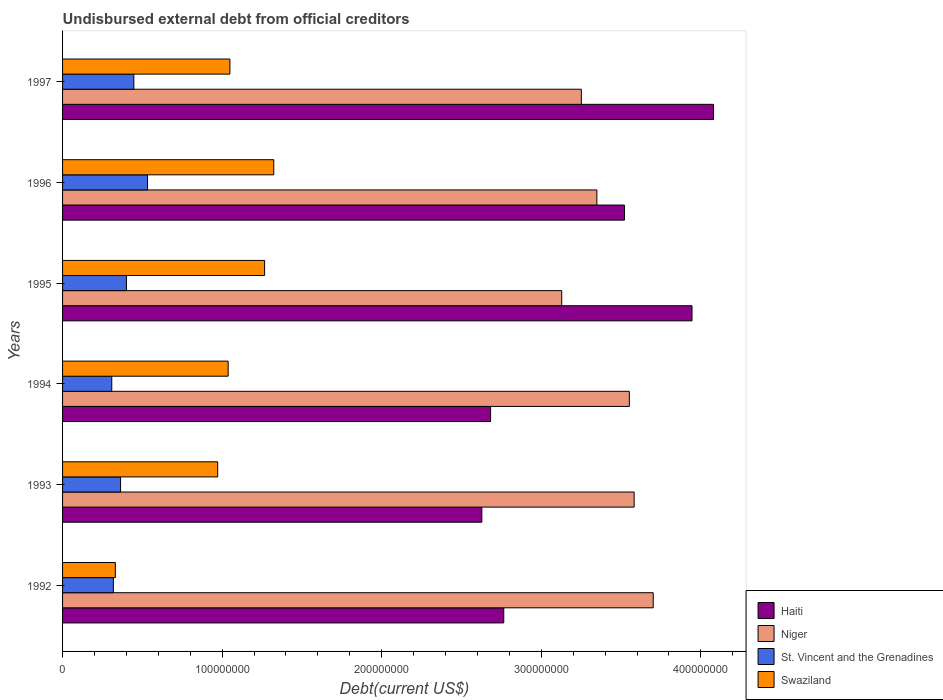Are the number of bars per tick equal to the number of legend labels?
Provide a succinct answer. Yes. Are the number of bars on each tick of the Y-axis equal?
Offer a terse response. Yes. What is the total debt in Haiti in 1997?
Provide a short and direct response. 4.08e+08. Across all years, what is the maximum total debt in Swaziland?
Offer a very short reply. 1.32e+08. Across all years, what is the minimum total debt in Niger?
Make the answer very short. 3.13e+08. In which year was the total debt in Haiti minimum?
Your answer should be compact. 1993. What is the total total debt in Haiti in the graph?
Your response must be concise. 1.96e+09. What is the difference between the total debt in St. Vincent and the Grenadines in 1995 and that in 1997?
Provide a succinct answer. -4.65e+06. What is the difference between the total debt in St. Vincent and the Grenadines in 1992 and the total debt in Niger in 1996?
Provide a succinct answer. -3.03e+08. What is the average total debt in Haiti per year?
Provide a short and direct response. 3.27e+08. In the year 1992, what is the difference between the total debt in St. Vincent and the Grenadines and total debt in Haiti?
Offer a very short reply. -2.45e+08. What is the ratio of the total debt in Haiti in 1995 to that in 1997?
Keep it short and to the point. 0.97. Is the total debt in Swaziland in 1992 less than that in 1996?
Your answer should be very brief. Yes. Is the difference between the total debt in St. Vincent and the Grenadines in 1994 and 1996 greater than the difference between the total debt in Haiti in 1994 and 1996?
Make the answer very short. Yes. What is the difference between the highest and the second highest total debt in Swaziland?
Your answer should be very brief. 5.76e+06. What is the difference between the highest and the lowest total debt in Swaziland?
Keep it short and to the point. 9.93e+07. In how many years, is the total debt in Niger greater than the average total debt in Niger taken over all years?
Your answer should be compact. 3. Is the sum of the total debt in Niger in 1993 and 1995 greater than the maximum total debt in Swaziland across all years?
Provide a succinct answer. Yes. Is it the case that in every year, the sum of the total debt in St. Vincent and the Grenadines and total debt in Swaziland is greater than the sum of total debt in Niger and total debt in Haiti?
Provide a short and direct response. No. What does the 1st bar from the top in 1993 represents?
Offer a very short reply. Swaziland. What does the 4th bar from the bottom in 1996 represents?
Provide a succinct answer. Swaziland. Is it the case that in every year, the sum of the total debt in Swaziland and total debt in Niger is greater than the total debt in St. Vincent and the Grenadines?
Give a very brief answer. Yes. How many bars are there?
Your answer should be very brief. 24. How many years are there in the graph?
Give a very brief answer. 6. Are the values on the major ticks of X-axis written in scientific E-notation?
Your answer should be compact. No. Where does the legend appear in the graph?
Offer a terse response. Bottom right. How many legend labels are there?
Give a very brief answer. 4. How are the legend labels stacked?
Ensure brevity in your answer.  Vertical. What is the title of the graph?
Your response must be concise. Undisbursed external debt from official creditors. What is the label or title of the X-axis?
Your response must be concise. Debt(current US$). What is the label or title of the Y-axis?
Offer a terse response. Years. What is the Debt(current US$) of Haiti in 1992?
Provide a short and direct response. 2.76e+08. What is the Debt(current US$) in Niger in 1992?
Give a very brief answer. 3.70e+08. What is the Debt(current US$) in St. Vincent and the Grenadines in 1992?
Ensure brevity in your answer.  3.18e+07. What is the Debt(current US$) in Swaziland in 1992?
Keep it short and to the point. 3.31e+07. What is the Debt(current US$) of Haiti in 1993?
Your answer should be compact. 2.63e+08. What is the Debt(current US$) of Niger in 1993?
Your answer should be very brief. 3.58e+08. What is the Debt(current US$) of St. Vincent and the Grenadines in 1993?
Your answer should be compact. 3.64e+07. What is the Debt(current US$) in Swaziland in 1993?
Your response must be concise. 9.72e+07. What is the Debt(current US$) in Haiti in 1994?
Provide a short and direct response. 2.68e+08. What is the Debt(current US$) of Niger in 1994?
Provide a succinct answer. 3.55e+08. What is the Debt(current US$) of St. Vincent and the Grenadines in 1994?
Offer a terse response. 3.08e+07. What is the Debt(current US$) of Swaziland in 1994?
Offer a very short reply. 1.04e+08. What is the Debt(current US$) in Haiti in 1995?
Make the answer very short. 3.94e+08. What is the Debt(current US$) in Niger in 1995?
Your answer should be very brief. 3.13e+08. What is the Debt(current US$) of St. Vincent and the Grenadines in 1995?
Keep it short and to the point. 4.00e+07. What is the Debt(current US$) in Swaziland in 1995?
Make the answer very short. 1.27e+08. What is the Debt(current US$) in Haiti in 1996?
Ensure brevity in your answer.  3.52e+08. What is the Debt(current US$) of Niger in 1996?
Offer a terse response. 3.35e+08. What is the Debt(current US$) in St. Vincent and the Grenadines in 1996?
Provide a short and direct response. 5.33e+07. What is the Debt(current US$) in Swaziland in 1996?
Provide a succinct answer. 1.32e+08. What is the Debt(current US$) of Haiti in 1997?
Offer a very short reply. 4.08e+08. What is the Debt(current US$) in Niger in 1997?
Your answer should be very brief. 3.25e+08. What is the Debt(current US$) of St. Vincent and the Grenadines in 1997?
Provide a succinct answer. 4.47e+07. What is the Debt(current US$) in Swaziland in 1997?
Give a very brief answer. 1.05e+08. Across all years, what is the maximum Debt(current US$) of Haiti?
Your response must be concise. 4.08e+08. Across all years, what is the maximum Debt(current US$) in Niger?
Your answer should be compact. 3.70e+08. Across all years, what is the maximum Debt(current US$) of St. Vincent and the Grenadines?
Your response must be concise. 5.33e+07. Across all years, what is the maximum Debt(current US$) of Swaziland?
Provide a succinct answer. 1.32e+08. Across all years, what is the minimum Debt(current US$) in Haiti?
Make the answer very short. 2.63e+08. Across all years, what is the minimum Debt(current US$) of Niger?
Provide a succinct answer. 3.13e+08. Across all years, what is the minimum Debt(current US$) of St. Vincent and the Grenadines?
Your response must be concise. 3.08e+07. Across all years, what is the minimum Debt(current US$) of Swaziland?
Keep it short and to the point. 3.31e+07. What is the total Debt(current US$) of Haiti in the graph?
Offer a terse response. 1.96e+09. What is the total Debt(current US$) of Niger in the graph?
Give a very brief answer. 2.06e+09. What is the total Debt(current US$) of St. Vincent and the Grenadines in the graph?
Your answer should be compact. 2.37e+08. What is the total Debt(current US$) in Swaziland in the graph?
Provide a succinct answer. 5.98e+08. What is the difference between the Debt(current US$) of Haiti in 1992 and that in 1993?
Your response must be concise. 1.37e+07. What is the difference between the Debt(current US$) of Niger in 1992 and that in 1993?
Keep it short and to the point. 1.20e+07. What is the difference between the Debt(current US$) of St. Vincent and the Grenadines in 1992 and that in 1993?
Provide a succinct answer. -4.53e+06. What is the difference between the Debt(current US$) in Swaziland in 1992 and that in 1993?
Provide a succinct answer. -6.41e+07. What is the difference between the Debt(current US$) of Haiti in 1992 and that in 1994?
Your answer should be very brief. 8.25e+06. What is the difference between the Debt(current US$) of Niger in 1992 and that in 1994?
Your answer should be very brief. 1.50e+07. What is the difference between the Debt(current US$) of St. Vincent and the Grenadines in 1992 and that in 1994?
Your response must be concise. 9.99e+05. What is the difference between the Debt(current US$) of Swaziland in 1992 and that in 1994?
Make the answer very short. -7.07e+07. What is the difference between the Debt(current US$) of Haiti in 1992 and that in 1995?
Provide a short and direct response. -1.18e+08. What is the difference between the Debt(current US$) of Niger in 1992 and that in 1995?
Your answer should be compact. 5.73e+07. What is the difference between the Debt(current US$) of St. Vincent and the Grenadines in 1992 and that in 1995?
Provide a succinct answer. -8.20e+06. What is the difference between the Debt(current US$) in Swaziland in 1992 and that in 1995?
Offer a very short reply. -9.35e+07. What is the difference between the Debt(current US$) in Haiti in 1992 and that in 1996?
Give a very brief answer. -7.57e+07. What is the difference between the Debt(current US$) of Niger in 1992 and that in 1996?
Your answer should be compact. 3.53e+07. What is the difference between the Debt(current US$) of St. Vincent and the Grenadines in 1992 and that in 1996?
Make the answer very short. -2.14e+07. What is the difference between the Debt(current US$) in Swaziland in 1992 and that in 1996?
Provide a short and direct response. -9.93e+07. What is the difference between the Debt(current US$) of Haiti in 1992 and that in 1997?
Your answer should be very brief. -1.31e+08. What is the difference between the Debt(current US$) of Niger in 1992 and that in 1997?
Your response must be concise. 4.50e+07. What is the difference between the Debt(current US$) in St. Vincent and the Grenadines in 1992 and that in 1997?
Offer a terse response. -1.28e+07. What is the difference between the Debt(current US$) in Swaziland in 1992 and that in 1997?
Offer a terse response. -7.18e+07. What is the difference between the Debt(current US$) of Haiti in 1993 and that in 1994?
Make the answer very short. -5.49e+06. What is the difference between the Debt(current US$) of Niger in 1993 and that in 1994?
Make the answer very short. 3.01e+06. What is the difference between the Debt(current US$) in St. Vincent and the Grenadines in 1993 and that in 1994?
Give a very brief answer. 5.52e+06. What is the difference between the Debt(current US$) of Swaziland in 1993 and that in 1994?
Offer a very short reply. -6.55e+06. What is the difference between the Debt(current US$) in Haiti in 1993 and that in 1995?
Provide a short and direct response. -1.32e+08. What is the difference between the Debt(current US$) in Niger in 1993 and that in 1995?
Give a very brief answer. 4.54e+07. What is the difference between the Debt(current US$) of St. Vincent and the Grenadines in 1993 and that in 1995?
Your answer should be very brief. -3.68e+06. What is the difference between the Debt(current US$) of Swaziland in 1993 and that in 1995?
Ensure brevity in your answer.  -2.94e+07. What is the difference between the Debt(current US$) of Haiti in 1993 and that in 1996?
Your response must be concise. -8.94e+07. What is the difference between the Debt(current US$) in Niger in 1993 and that in 1996?
Offer a terse response. 2.34e+07. What is the difference between the Debt(current US$) of St. Vincent and the Grenadines in 1993 and that in 1996?
Offer a very short reply. -1.69e+07. What is the difference between the Debt(current US$) in Swaziland in 1993 and that in 1996?
Offer a very short reply. -3.51e+07. What is the difference between the Debt(current US$) of Haiti in 1993 and that in 1997?
Ensure brevity in your answer.  -1.45e+08. What is the difference between the Debt(current US$) in Niger in 1993 and that in 1997?
Offer a terse response. 3.31e+07. What is the difference between the Debt(current US$) of St. Vincent and the Grenadines in 1993 and that in 1997?
Ensure brevity in your answer.  -8.32e+06. What is the difference between the Debt(current US$) in Swaziland in 1993 and that in 1997?
Provide a short and direct response. -7.65e+06. What is the difference between the Debt(current US$) in Haiti in 1994 and that in 1995?
Keep it short and to the point. -1.26e+08. What is the difference between the Debt(current US$) in Niger in 1994 and that in 1995?
Offer a terse response. 4.24e+07. What is the difference between the Debt(current US$) in St. Vincent and the Grenadines in 1994 and that in 1995?
Your answer should be very brief. -9.20e+06. What is the difference between the Debt(current US$) of Swaziland in 1994 and that in 1995?
Keep it short and to the point. -2.28e+07. What is the difference between the Debt(current US$) of Haiti in 1994 and that in 1996?
Ensure brevity in your answer.  -8.39e+07. What is the difference between the Debt(current US$) in Niger in 1994 and that in 1996?
Provide a succinct answer. 2.03e+07. What is the difference between the Debt(current US$) in St. Vincent and the Grenadines in 1994 and that in 1996?
Provide a succinct answer. -2.24e+07. What is the difference between the Debt(current US$) in Swaziland in 1994 and that in 1996?
Offer a terse response. -2.86e+07. What is the difference between the Debt(current US$) in Haiti in 1994 and that in 1997?
Offer a terse response. -1.40e+08. What is the difference between the Debt(current US$) in Niger in 1994 and that in 1997?
Offer a terse response. 3.01e+07. What is the difference between the Debt(current US$) in St. Vincent and the Grenadines in 1994 and that in 1997?
Ensure brevity in your answer.  -1.38e+07. What is the difference between the Debt(current US$) of Swaziland in 1994 and that in 1997?
Your response must be concise. -1.10e+06. What is the difference between the Debt(current US$) of Haiti in 1995 and that in 1996?
Your response must be concise. 4.23e+07. What is the difference between the Debt(current US$) of Niger in 1995 and that in 1996?
Make the answer very short. -2.20e+07. What is the difference between the Debt(current US$) in St. Vincent and the Grenadines in 1995 and that in 1996?
Keep it short and to the point. -1.32e+07. What is the difference between the Debt(current US$) of Swaziland in 1995 and that in 1996?
Your answer should be compact. -5.76e+06. What is the difference between the Debt(current US$) of Haiti in 1995 and that in 1997?
Provide a short and direct response. -1.35e+07. What is the difference between the Debt(current US$) of Niger in 1995 and that in 1997?
Offer a terse response. -1.23e+07. What is the difference between the Debt(current US$) in St. Vincent and the Grenadines in 1995 and that in 1997?
Your answer should be very brief. -4.65e+06. What is the difference between the Debt(current US$) in Swaziland in 1995 and that in 1997?
Ensure brevity in your answer.  2.17e+07. What is the difference between the Debt(current US$) in Haiti in 1996 and that in 1997?
Keep it short and to the point. -5.58e+07. What is the difference between the Debt(current US$) of Niger in 1996 and that in 1997?
Ensure brevity in your answer.  9.73e+06. What is the difference between the Debt(current US$) of St. Vincent and the Grenadines in 1996 and that in 1997?
Your answer should be very brief. 8.58e+06. What is the difference between the Debt(current US$) of Swaziland in 1996 and that in 1997?
Your answer should be very brief. 2.75e+07. What is the difference between the Debt(current US$) of Haiti in 1992 and the Debt(current US$) of Niger in 1993?
Provide a succinct answer. -8.17e+07. What is the difference between the Debt(current US$) in Haiti in 1992 and the Debt(current US$) in St. Vincent and the Grenadines in 1993?
Your answer should be compact. 2.40e+08. What is the difference between the Debt(current US$) in Haiti in 1992 and the Debt(current US$) in Swaziland in 1993?
Offer a very short reply. 1.79e+08. What is the difference between the Debt(current US$) of Niger in 1992 and the Debt(current US$) of St. Vincent and the Grenadines in 1993?
Ensure brevity in your answer.  3.34e+08. What is the difference between the Debt(current US$) in Niger in 1992 and the Debt(current US$) in Swaziland in 1993?
Your answer should be compact. 2.73e+08. What is the difference between the Debt(current US$) in St. Vincent and the Grenadines in 1992 and the Debt(current US$) in Swaziland in 1993?
Give a very brief answer. -6.54e+07. What is the difference between the Debt(current US$) of Haiti in 1992 and the Debt(current US$) of Niger in 1994?
Make the answer very short. -7.87e+07. What is the difference between the Debt(current US$) in Haiti in 1992 and the Debt(current US$) in St. Vincent and the Grenadines in 1994?
Provide a succinct answer. 2.46e+08. What is the difference between the Debt(current US$) in Haiti in 1992 and the Debt(current US$) in Swaziland in 1994?
Keep it short and to the point. 1.73e+08. What is the difference between the Debt(current US$) of Niger in 1992 and the Debt(current US$) of St. Vincent and the Grenadines in 1994?
Offer a terse response. 3.39e+08. What is the difference between the Debt(current US$) in Niger in 1992 and the Debt(current US$) in Swaziland in 1994?
Keep it short and to the point. 2.66e+08. What is the difference between the Debt(current US$) in St. Vincent and the Grenadines in 1992 and the Debt(current US$) in Swaziland in 1994?
Offer a terse response. -7.19e+07. What is the difference between the Debt(current US$) in Haiti in 1992 and the Debt(current US$) in Niger in 1995?
Your answer should be very brief. -3.63e+07. What is the difference between the Debt(current US$) of Haiti in 1992 and the Debt(current US$) of St. Vincent and the Grenadines in 1995?
Provide a short and direct response. 2.36e+08. What is the difference between the Debt(current US$) of Haiti in 1992 and the Debt(current US$) of Swaziland in 1995?
Your answer should be very brief. 1.50e+08. What is the difference between the Debt(current US$) in Niger in 1992 and the Debt(current US$) in St. Vincent and the Grenadines in 1995?
Your response must be concise. 3.30e+08. What is the difference between the Debt(current US$) of Niger in 1992 and the Debt(current US$) of Swaziland in 1995?
Your answer should be compact. 2.44e+08. What is the difference between the Debt(current US$) in St. Vincent and the Grenadines in 1992 and the Debt(current US$) in Swaziland in 1995?
Your answer should be compact. -9.48e+07. What is the difference between the Debt(current US$) in Haiti in 1992 and the Debt(current US$) in Niger in 1996?
Provide a succinct answer. -5.84e+07. What is the difference between the Debt(current US$) of Haiti in 1992 and the Debt(current US$) of St. Vincent and the Grenadines in 1996?
Ensure brevity in your answer.  2.23e+08. What is the difference between the Debt(current US$) of Haiti in 1992 and the Debt(current US$) of Swaziland in 1996?
Ensure brevity in your answer.  1.44e+08. What is the difference between the Debt(current US$) of Niger in 1992 and the Debt(current US$) of St. Vincent and the Grenadines in 1996?
Give a very brief answer. 3.17e+08. What is the difference between the Debt(current US$) in Niger in 1992 and the Debt(current US$) in Swaziland in 1996?
Your response must be concise. 2.38e+08. What is the difference between the Debt(current US$) in St. Vincent and the Grenadines in 1992 and the Debt(current US$) in Swaziland in 1996?
Offer a terse response. -1.01e+08. What is the difference between the Debt(current US$) of Haiti in 1992 and the Debt(current US$) of Niger in 1997?
Keep it short and to the point. -4.86e+07. What is the difference between the Debt(current US$) of Haiti in 1992 and the Debt(current US$) of St. Vincent and the Grenadines in 1997?
Your response must be concise. 2.32e+08. What is the difference between the Debt(current US$) in Haiti in 1992 and the Debt(current US$) in Swaziland in 1997?
Your answer should be compact. 1.72e+08. What is the difference between the Debt(current US$) in Niger in 1992 and the Debt(current US$) in St. Vincent and the Grenadines in 1997?
Keep it short and to the point. 3.25e+08. What is the difference between the Debt(current US$) in Niger in 1992 and the Debt(current US$) in Swaziland in 1997?
Offer a very short reply. 2.65e+08. What is the difference between the Debt(current US$) in St. Vincent and the Grenadines in 1992 and the Debt(current US$) in Swaziland in 1997?
Your response must be concise. -7.30e+07. What is the difference between the Debt(current US$) in Haiti in 1993 and the Debt(current US$) in Niger in 1994?
Make the answer very short. -9.24e+07. What is the difference between the Debt(current US$) in Haiti in 1993 and the Debt(current US$) in St. Vincent and the Grenadines in 1994?
Ensure brevity in your answer.  2.32e+08. What is the difference between the Debt(current US$) in Haiti in 1993 and the Debt(current US$) in Swaziland in 1994?
Keep it short and to the point. 1.59e+08. What is the difference between the Debt(current US$) in Niger in 1993 and the Debt(current US$) in St. Vincent and the Grenadines in 1994?
Ensure brevity in your answer.  3.27e+08. What is the difference between the Debt(current US$) in Niger in 1993 and the Debt(current US$) in Swaziland in 1994?
Provide a short and direct response. 2.54e+08. What is the difference between the Debt(current US$) in St. Vincent and the Grenadines in 1993 and the Debt(current US$) in Swaziland in 1994?
Ensure brevity in your answer.  -6.74e+07. What is the difference between the Debt(current US$) in Haiti in 1993 and the Debt(current US$) in Niger in 1995?
Provide a succinct answer. -5.01e+07. What is the difference between the Debt(current US$) in Haiti in 1993 and the Debt(current US$) in St. Vincent and the Grenadines in 1995?
Your answer should be compact. 2.23e+08. What is the difference between the Debt(current US$) of Haiti in 1993 and the Debt(current US$) of Swaziland in 1995?
Ensure brevity in your answer.  1.36e+08. What is the difference between the Debt(current US$) in Niger in 1993 and the Debt(current US$) in St. Vincent and the Grenadines in 1995?
Make the answer very short. 3.18e+08. What is the difference between the Debt(current US$) of Niger in 1993 and the Debt(current US$) of Swaziland in 1995?
Keep it short and to the point. 2.32e+08. What is the difference between the Debt(current US$) of St. Vincent and the Grenadines in 1993 and the Debt(current US$) of Swaziland in 1995?
Make the answer very short. -9.02e+07. What is the difference between the Debt(current US$) of Haiti in 1993 and the Debt(current US$) of Niger in 1996?
Your response must be concise. -7.21e+07. What is the difference between the Debt(current US$) of Haiti in 1993 and the Debt(current US$) of St. Vincent and the Grenadines in 1996?
Your response must be concise. 2.10e+08. What is the difference between the Debt(current US$) of Haiti in 1993 and the Debt(current US$) of Swaziland in 1996?
Offer a terse response. 1.30e+08. What is the difference between the Debt(current US$) in Niger in 1993 and the Debt(current US$) in St. Vincent and the Grenadines in 1996?
Offer a very short reply. 3.05e+08. What is the difference between the Debt(current US$) in Niger in 1993 and the Debt(current US$) in Swaziland in 1996?
Keep it short and to the point. 2.26e+08. What is the difference between the Debt(current US$) of St. Vincent and the Grenadines in 1993 and the Debt(current US$) of Swaziland in 1996?
Offer a very short reply. -9.60e+07. What is the difference between the Debt(current US$) in Haiti in 1993 and the Debt(current US$) in Niger in 1997?
Provide a succinct answer. -6.24e+07. What is the difference between the Debt(current US$) of Haiti in 1993 and the Debt(current US$) of St. Vincent and the Grenadines in 1997?
Your response must be concise. 2.18e+08. What is the difference between the Debt(current US$) of Haiti in 1993 and the Debt(current US$) of Swaziland in 1997?
Ensure brevity in your answer.  1.58e+08. What is the difference between the Debt(current US$) in Niger in 1993 and the Debt(current US$) in St. Vincent and the Grenadines in 1997?
Ensure brevity in your answer.  3.14e+08. What is the difference between the Debt(current US$) of Niger in 1993 and the Debt(current US$) of Swaziland in 1997?
Your answer should be compact. 2.53e+08. What is the difference between the Debt(current US$) in St. Vincent and the Grenadines in 1993 and the Debt(current US$) in Swaziland in 1997?
Make the answer very short. -6.85e+07. What is the difference between the Debt(current US$) of Haiti in 1994 and the Debt(current US$) of Niger in 1995?
Your response must be concise. -4.46e+07. What is the difference between the Debt(current US$) in Haiti in 1994 and the Debt(current US$) in St. Vincent and the Grenadines in 1995?
Give a very brief answer. 2.28e+08. What is the difference between the Debt(current US$) of Haiti in 1994 and the Debt(current US$) of Swaziland in 1995?
Offer a very short reply. 1.42e+08. What is the difference between the Debt(current US$) of Niger in 1994 and the Debt(current US$) of St. Vincent and the Grenadines in 1995?
Your answer should be compact. 3.15e+08. What is the difference between the Debt(current US$) in Niger in 1994 and the Debt(current US$) in Swaziland in 1995?
Keep it short and to the point. 2.29e+08. What is the difference between the Debt(current US$) in St. Vincent and the Grenadines in 1994 and the Debt(current US$) in Swaziland in 1995?
Your answer should be very brief. -9.58e+07. What is the difference between the Debt(current US$) in Haiti in 1994 and the Debt(current US$) in Niger in 1996?
Make the answer very short. -6.66e+07. What is the difference between the Debt(current US$) in Haiti in 1994 and the Debt(current US$) in St. Vincent and the Grenadines in 1996?
Offer a very short reply. 2.15e+08. What is the difference between the Debt(current US$) of Haiti in 1994 and the Debt(current US$) of Swaziland in 1996?
Make the answer very short. 1.36e+08. What is the difference between the Debt(current US$) in Niger in 1994 and the Debt(current US$) in St. Vincent and the Grenadines in 1996?
Make the answer very short. 3.02e+08. What is the difference between the Debt(current US$) in Niger in 1994 and the Debt(current US$) in Swaziland in 1996?
Offer a very short reply. 2.23e+08. What is the difference between the Debt(current US$) in St. Vincent and the Grenadines in 1994 and the Debt(current US$) in Swaziland in 1996?
Keep it short and to the point. -1.02e+08. What is the difference between the Debt(current US$) in Haiti in 1994 and the Debt(current US$) in Niger in 1997?
Your answer should be compact. -5.69e+07. What is the difference between the Debt(current US$) in Haiti in 1994 and the Debt(current US$) in St. Vincent and the Grenadines in 1997?
Provide a short and direct response. 2.24e+08. What is the difference between the Debt(current US$) in Haiti in 1994 and the Debt(current US$) in Swaziland in 1997?
Your answer should be very brief. 1.63e+08. What is the difference between the Debt(current US$) of Niger in 1994 and the Debt(current US$) of St. Vincent and the Grenadines in 1997?
Provide a succinct answer. 3.11e+08. What is the difference between the Debt(current US$) of Niger in 1994 and the Debt(current US$) of Swaziland in 1997?
Your answer should be very brief. 2.50e+08. What is the difference between the Debt(current US$) of St. Vincent and the Grenadines in 1994 and the Debt(current US$) of Swaziland in 1997?
Your answer should be very brief. -7.40e+07. What is the difference between the Debt(current US$) in Haiti in 1995 and the Debt(current US$) in Niger in 1996?
Give a very brief answer. 5.96e+07. What is the difference between the Debt(current US$) of Haiti in 1995 and the Debt(current US$) of St. Vincent and the Grenadines in 1996?
Offer a terse response. 3.41e+08. What is the difference between the Debt(current US$) of Haiti in 1995 and the Debt(current US$) of Swaziland in 1996?
Make the answer very short. 2.62e+08. What is the difference between the Debt(current US$) in Niger in 1995 and the Debt(current US$) in St. Vincent and the Grenadines in 1996?
Ensure brevity in your answer.  2.60e+08. What is the difference between the Debt(current US$) of Niger in 1995 and the Debt(current US$) of Swaziland in 1996?
Your answer should be compact. 1.80e+08. What is the difference between the Debt(current US$) in St. Vincent and the Grenadines in 1995 and the Debt(current US$) in Swaziland in 1996?
Give a very brief answer. -9.23e+07. What is the difference between the Debt(current US$) of Haiti in 1995 and the Debt(current US$) of Niger in 1997?
Provide a short and direct response. 6.94e+07. What is the difference between the Debt(current US$) of Haiti in 1995 and the Debt(current US$) of St. Vincent and the Grenadines in 1997?
Make the answer very short. 3.50e+08. What is the difference between the Debt(current US$) of Haiti in 1995 and the Debt(current US$) of Swaziland in 1997?
Provide a succinct answer. 2.90e+08. What is the difference between the Debt(current US$) of Niger in 1995 and the Debt(current US$) of St. Vincent and the Grenadines in 1997?
Give a very brief answer. 2.68e+08. What is the difference between the Debt(current US$) of Niger in 1995 and the Debt(current US$) of Swaziland in 1997?
Offer a terse response. 2.08e+08. What is the difference between the Debt(current US$) of St. Vincent and the Grenadines in 1995 and the Debt(current US$) of Swaziland in 1997?
Your answer should be very brief. -6.48e+07. What is the difference between the Debt(current US$) of Haiti in 1996 and the Debt(current US$) of Niger in 1997?
Offer a terse response. 2.70e+07. What is the difference between the Debt(current US$) of Haiti in 1996 and the Debt(current US$) of St. Vincent and the Grenadines in 1997?
Your answer should be very brief. 3.07e+08. What is the difference between the Debt(current US$) of Haiti in 1996 and the Debt(current US$) of Swaziland in 1997?
Keep it short and to the point. 2.47e+08. What is the difference between the Debt(current US$) in Niger in 1996 and the Debt(current US$) in St. Vincent and the Grenadines in 1997?
Ensure brevity in your answer.  2.90e+08. What is the difference between the Debt(current US$) in Niger in 1996 and the Debt(current US$) in Swaziland in 1997?
Your answer should be very brief. 2.30e+08. What is the difference between the Debt(current US$) in St. Vincent and the Grenadines in 1996 and the Debt(current US$) in Swaziland in 1997?
Keep it short and to the point. -5.16e+07. What is the average Debt(current US$) in Haiti per year?
Provide a short and direct response. 3.27e+08. What is the average Debt(current US$) in Niger per year?
Give a very brief answer. 3.43e+08. What is the average Debt(current US$) in St. Vincent and the Grenadines per year?
Provide a short and direct response. 3.95e+07. What is the average Debt(current US$) in Swaziland per year?
Give a very brief answer. 9.97e+07. In the year 1992, what is the difference between the Debt(current US$) in Haiti and Debt(current US$) in Niger?
Provide a succinct answer. -9.37e+07. In the year 1992, what is the difference between the Debt(current US$) of Haiti and Debt(current US$) of St. Vincent and the Grenadines?
Your answer should be very brief. 2.45e+08. In the year 1992, what is the difference between the Debt(current US$) in Haiti and Debt(current US$) in Swaziland?
Ensure brevity in your answer.  2.43e+08. In the year 1992, what is the difference between the Debt(current US$) in Niger and Debt(current US$) in St. Vincent and the Grenadines?
Keep it short and to the point. 3.38e+08. In the year 1992, what is the difference between the Debt(current US$) of Niger and Debt(current US$) of Swaziland?
Provide a short and direct response. 3.37e+08. In the year 1992, what is the difference between the Debt(current US$) of St. Vincent and the Grenadines and Debt(current US$) of Swaziland?
Your response must be concise. -1.25e+06. In the year 1993, what is the difference between the Debt(current US$) in Haiti and Debt(current US$) in Niger?
Offer a very short reply. -9.54e+07. In the year 1993, what is the difference between the Debt(current US$) in Haiti and Debt(current US$) in St. Vincent and the Grenadines?
Provide a short and direct response. 2.26e+08. In the year 1993, what is the difference between the Debt(current US$) of Haiti and Debt(current US$) of Swaziland?
Give a very brief answer. 1.66e+08. In the year 1993, what is the difference between the Debt(current US$) in Niger and Debt(current US$) in St. Vincent and the Grenadines?
Offer a terse response. 3.22e+08. In the year 1993, what is the difference between the Debt(current US$) in Niger and Debt(current US$) in Swaziland?
Provide a succinct answer. 2.61e+08. In the year 1993, what is the difference between the Debt(current US$) of St. Vincent and the Grenadines and Debt(current US$) of Swaziland?
Keep it short and to the point. -6.09e+07. In the year 1994, what is the difference between the Debt(current US$) of Haiti and Debt(current US$) of Niger?
Make the answer very short. -8.69e+07. In the year 1994, what is the difference between the Debt(current US$) of Haiti and Debt(current US$) of St. Vincent and the Grenadines?
Offer a terse response. 2.37e+08. In the year 1994, what is the difference between the Debt(current US$) in Haiti and Debt(current US$) in Swaziland?
Offer a very short reply. 1.64e+08. In the year 1994, what is the difference between the Debt(current US$) in Niger and Debt(current US$) in St. Vincent and the Grenadines?
Your answer should be compact. 3.24e+08. In the year 1994, what is the difference between the Debt(current US$) of Niger and Debt(current US$) of Swaziland?
Your response must be concise. 2.51e+08. In the year 1994, what is the difference between the Debt(current US$) of St. Vincent and the Grenadines and Debt(current US$) of Swaziland?
Ensure brevity in your answer.  -7.29e+07. In the year 1995, what is the difference between the Debt(current US$) of Haiti and Debt(current US$) of Niger?
Provide a succinct answer. 8.17e+07. In the year 1995, what is the difference between the Debt(current US$) of Haiti and Debt(current US$) of St. Vincent and the Grenadines?
Your response must be concise. 3.54e+08. In the year 1995, what is the difference between the Debt(current US$) of Haiti and Debt(current US$) of Swaziland?
Provide a succinct answer. 2.68e+08. In the year 1995, what is the difference between the Debt(current US$) of Niger and Debt(current US$) of St. Vincent and the Grenadines?
Offer a very short reply. 2.73e+08. In the year 1995, what is the difference between the Debt(current US$) of Niger and Debt(current US$) of Swaziland?
Offer a terse response. 1.86e+08. In the year 1995, what is the difference between the Debt(current US$) in St. Vincent and the Grenadines and Debt(current US$) in Swaziland?
Offer a terse response. -8.66e+07. In the year 1996, what is the difference between the Debt(current US$) in Haiti and Debt(current US$) in Niger?
Provide a short and direct response. 1.73e+07. In the year 1996, what is the difference between the Debt(current US$) in Haiti and Debt(current US$) in St. Vincent and the Grenadines?
Your response must be concise. 2.99e+08. In the year 1996, what is the difference between the Debt(current US$) of Haiti and Debt(current US$) of Swaziland?
Give a very brief answer. 2.20e+08. In the year 1996, what is the difference between the Debt(current US$) in Niger and Debt(current US$) in St. Vincent and the Grenadines?
Your answer should be compact. 2.82e+08. In the year 1996, what is the difference between the Debt(current US$) of Niger and Debt(current US$) of Swaziland?
Offer a terse response. 2.02e+08. In the year 1996, what is the difference between the Debt(current US$) of St. Vincent and the Grenadines and Debt(current US$) of Swaziland?
Provide a short and direct response. -7.91e+07. In the year 1997, what is the difference between the Debt(current US$) in Haiti and Debt(current US$) in Niger?
Ensure brevity in your answer.  8.28e+07. In the year 1997, what is the difference between the Debt(current US$) in Haiti and Debt(current US$) in St. Vincent and the Grenadines?
Offer a very short reply. 3.63e+08. In the year 1997, what is the difference between the Debt(current US$) of Haiti and Debt(current US$) of Swaziland?
Provide a succinct answer. 3.03e+08. In the year 1997, what is the difference between the Debt(current US$) in Niger and Debt(current US$) in St. Vincent and the Grenadines?
Provide a short and direct response. 2.80e+08. In the year 1997, what is the difference between the Debt(current US$) in Niger and Debt(current US$) in Swaziland?
Give a very brief answer. 2.20e+08. In the year 1997, what is the difference between the Debt(current US$) of St. Vincent and the Grenadines and Debt(current US$) of Swaziland?
Your answer should be very brief. -6.02e+07. What is the ratio of the Debt(current US$) of Haiti in 1992 to that in 1993?
Provide a succinct answer. 1.05. What is the ratio of the Debt(current US$) in Niger in 1992 to that in 1993?
Offer a terse response. 1.03. What is the ratio of the Debt(current US$) in St. Vincent and the Grenadines in 1992 to that in 1993?
Make the answer very short. 0.88. What is the ratio of the Debt(current US$) of Swaziland in 1992 to that in 1993?
Give a very brief answer. 0.34. What is the ratio of the Debt(current US$) in Haiti in 1992 to that in 1994?
Your answer should be very brief. 1.03. What is the ratio of the Debt(current US$) in Niger in 1992 to that in 1994?
Give a very brief answer. 1.04. What is the ratio of the Debt(current US$) in St. Vincent and the Grenadines in 1992 to that in 1994?
Provide a short and direct response. 1.03. What is the ratio of the Debt(current US$) of Swaziland in 1992 to that in 1994?
Ensure brevity in your answer.  0.32. What is the ratio of the Debt(current US$) of Haiti in 1992 to that in 1995?
Provide a succinct answer. 0.7. What is the ratio of the Debt(current US$) in Niger in 1992 to that in 1995?
Give a very brief answer. 1.18. What is the ratio of the Debt(current US$) of St. Vincent and the Grenadines in 1992 to that in 1995?
Ensure brevity in your answer.  0.8. What is the ratio of the Debt(current US$) in Swaziland in 1992 to that in 1995?
Offer a terse response. 0.26. What is the ratio of the Debt(current US$) in Haiti in 1992 to that in 1996?
Offer a very short reply. 0.79. What is the ratio of the Debt(current US$) of Niger in 1992 to that in 1996?
Keep it short and to the point. 1.11. What is the ratio of the Debt(current US$) of St. Vincent and the Grenadines in 1992 to that in 1996?
Give a very brief answer. 0.6. What is the ratio of the Debt(current US$) of Swaziland in 1992 to that in 1996?
Give a very brief answer. 0.25. What is the ratio of the Debt(current US$) in Haiti in 1992 to that in 1997?
Offer a very short reply. 0.68. What is the ratio of the Debt(current US$) in Niger in 1992 to that in 1997?
Offer a terse response. 1.14. What is the ratio of the Debt(current US$) in St. Vincent and the Grenadines in 1992 to that in 1997?
Your answer should be very brief. 0.71. What is the ratio of the Debt(current US$) of Swaziland in 1992 to that in 1997?
Offer a terse response. 0.32. What is the ratio of the Debt(current US$) in Haiti in 1993 to that in 1994?
Keep it short and to the point. 0.98. What is the ratio of the Debt(current US$) in Niger in 1993 to that in 1994?
Make the answer very short. 1.01. What is the ratio of the Debt(current US$) of St. Vincent and the Grenadines in 1993 to that in 1994?
Your answer should be compact. 1.18. What is the ratio of the Debt(current US$) of Swaziland in 1993 to that in 1994?
Provide a short and direct response. 0.94. What is the ratio of the Debt(current US$) in Haiti in 1993 to that in 1995?
Provide a succinct answer. 0.67. What is the ratio of the Debt(current US$) in Niger in 1993 to that in 1995?
Give a very brief answer. 1.15. What is the ratio of the Debt(current US$) of St. Vincent and the Grenadines in 1993 to that in 1995?
Keep it short and to the point. 0.91. What is the ratio of the Debt(current US$) in Swaziland in 1993 to that in 1995?
Your answer should be compact. 0.77. What is the ratio of the Debt(current US$) in Haiti in 1993 to that in 1996?
Provide a succinct answer. 0.75. What is the ratio of the Debt(current US$) of Niger in 1993 to that in 1996?
Provide a short and direct response. 1.07. What is the ratio of the Debt(current US$) of St. Vincent and the Grenadines in 1993 to that in 1996?
Provide a succinct answer. 0.68. What is the ratio of the Debt(current US$) in Swaziland in 1993 to that in 1996?
Your answer should be compact. 0.73. What is the ratio of the Debt(current US$) of Haiti in 1993 to that in 1997?
Provide a short and direct response. 0.64. What is the ratio of the Debt(current US$) of Niger in 1993 to that in 1997?
Provide a succinct answer. 1.1. What is the ratio of the Debt(current US$) of St. Vincent and the Grenadines in 1993 to that in 1997?
Give a very brief answer. 0.81. What is the ratio of the Debt(current US$) in Swaziland in 1993 to that in 1997?
Offer a very short reply. 0.93. What is the ratio of the Debt(current US$) of Haiti in 1994 to that in 1995?
Offer a very short reply. 0.68. What is the ratio of the Debt(current US$) of Niger in 1994 to that in 1995?
Give a very brief answer. 1.14. What is the ratio of the Debt(current US$) in St. Vincent and the Grenadines in 1994 to that in 1995?
Offer a very short reply. 0.77. What is the ratio of the Debt(current US$) in Swaziland in 1994 to that in 1995?
Make the answer very short. 0.82. What is the ratio of the Debt(current US$) of Haiti in 1994 to that in 1996?
Provide a short and direct response. 0.76. What is the ratio of the Debt(current US$) in Niger in 1994 to that in 1996?
Make the answer very short. 1.06. What is the ratio of the Debt(current US$) of St. Vincent and the Grenadines in 1994 to that in 1996?
Provide a short and direct response. 0.58. What is the ratio of the Debt(current US$) of Swaziland in 1994 to that in 1996?
Keep it short and to the point. 0.78. What is the ratio of the Debt(current US$) of Haiti in 1994 to that in 1997?
Your response must be concise. 0.66. What is the ratio of the Debt(current US$) in Niger in 1994 to that in 1997?
Make the answer very short. 1.09. What is the ratio of the Debt(current US$) in St. Vincent and the Grenadines in 1994 to that in 1997?
Give a very brief answer. 0.69. What is the ratio of the Debt(current US$) of Swaziland in 1994 to that in 1997?
Your response must be concise. 0.99. What is the ratio of the Debt(current US$) of Haiti in 1995 to that in 1996?
Your answer should be compact. 1.12. What is the ratio of the Debt(current US$) in Niger in 1995 to that in 1996?
Offer a terse response. 0.93. What is the ratio of the Debt(current US$) of St. Vincent and the Grenadines in 1995 to that in 1996?
Provide a short and direct response. 0.75. What is the ratio of the Debt(current US$) in Swaziland in 1995 to that in 1996?
Give a very brief answer. 0.96. What is the ratio of the Debt(current US$) in Haiti in 1995 to that in 1997?
Offer a terse response. 0.97. What is the ratio of the Debt(current US$) in Niger in 1995 to that in 1997?
Your answer should be compact. 0.96. What is the ratio of the Debt(current US$) in St. Vincent and the Grenadines in 1995 to that in 1997?
Give a very brief answer. 0.9. What is the ratio of the Debt(current US$) of Swaziland in 1995 to that in 1997?
Provide a succinct answer. 1.21. What is the ratio of the Debt(current US$) of Haiti in 1996 to that in 1997?
Your answer should be very brief. 0.86. What is the ratio of the Debt(current US$) in Niger in 1996 to that in 1997?
Your answer should be very brief. 1.03. What is the ratio of the Debt(current US$) in St. Vincent and the Grenadines in 1996 to that in 1997?
Give a very brief answer. 1.19. What is the ratio of the Debt(current US$) of Swaziland in 1996 to that in 1997?
Your answer should be very brief. 1.26. What is the difference between the highest and the second highest Debt(current US$) of Haiti?
Ensure brevity in your answer.  1.35e+07. What is the difference between the highest and the second highest Debt(current US$) in Niger?
Your response must be concise. 1.20e+07. What is the difference between the highest and the second highest Debt(current US$) of St. Vincent and the Grenadines?
Offer a terse response. 8.58e+06. What is the difference between the highest and the second highest Debt(current US$) in Swaziland?
Keep it short and to the point. 5.76e+06. What is the difference between the highest and the lowest Debt(current US$) of Haiti?
Provide a succinct answer. 1.45e+08. What is the difference between the highest and the lowest Debt(current US$) in Niger?
Make the answer very short. 5.73e+07. What is the difference between the highest and the lowest Debt(current US$) in St. Vincent and the Grenadines?
Provide a short and direct response. 2.24e+07. What is the difference between the highest and the lowest Debt(current US$) of Swaziland?
Keep it short and to the point. 9.93e+07. 